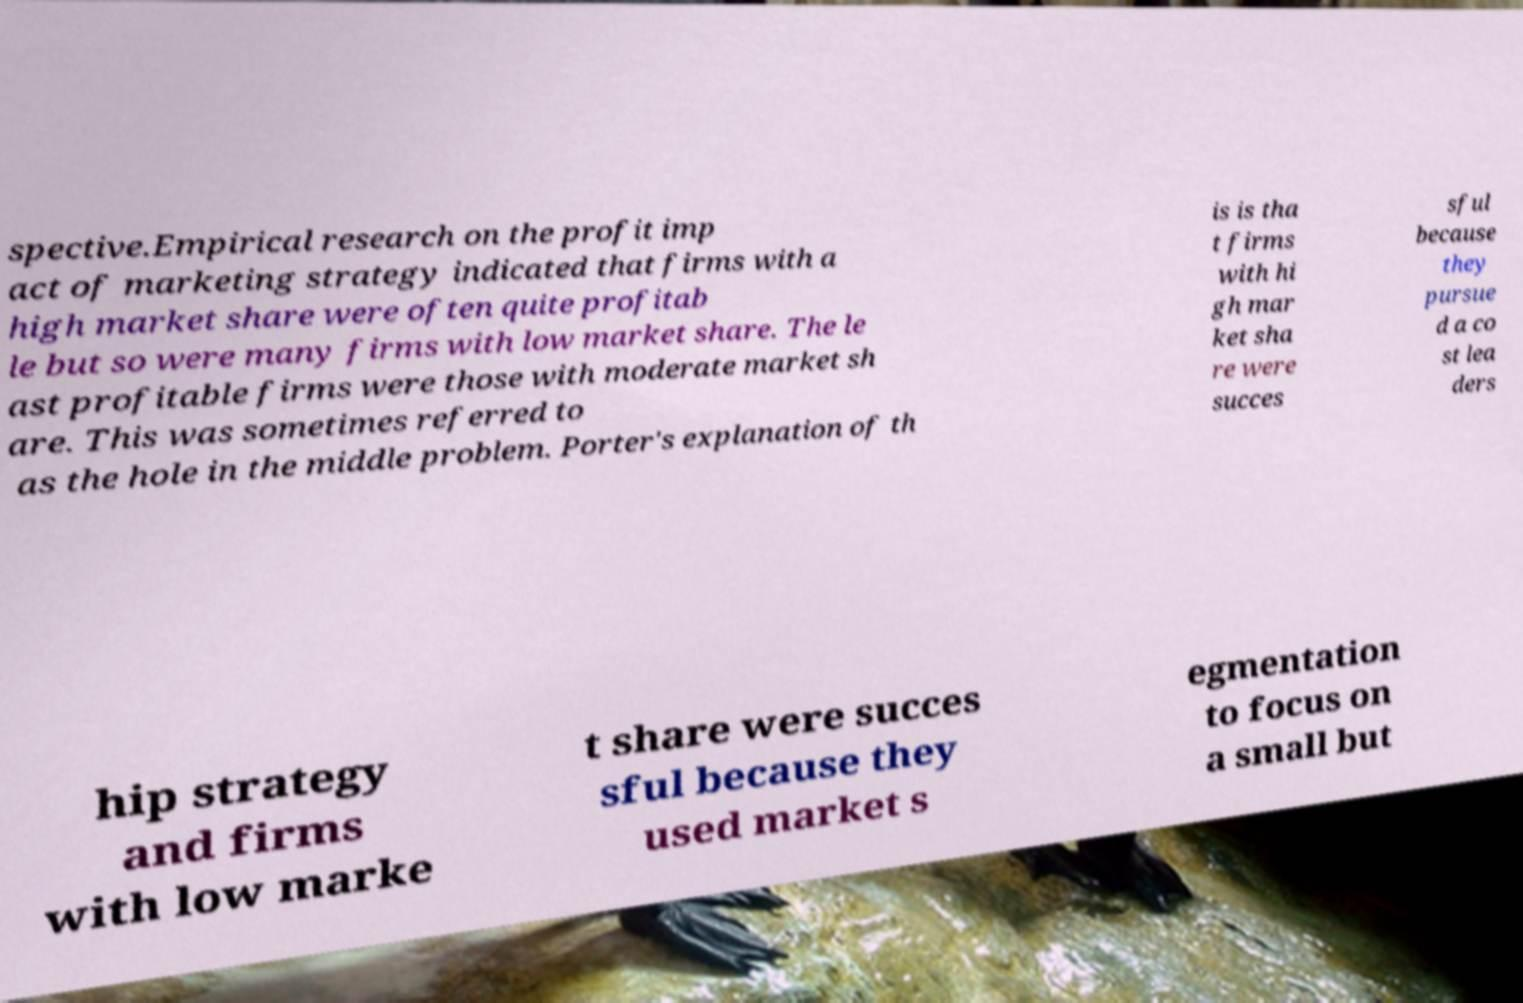What messages or text are displayed in this image? I need them in a readable, typed format. spective.Empirical research on the profit imp act of marketing strategy indicated that firms with a high market share were often quite profitab le but so were many firms with low market share. The le ast profitable firms were those with moderate market sh are. This was sometimes referred to as the hole in the middle problem. Porter's explanation of th is is tha t firms with hi gh mar ket sha re were succes sful because they pursue d a co st lea ders hip strategy and firms with low marke t share were succes sful because they used market s egmentation to focus on a small but 